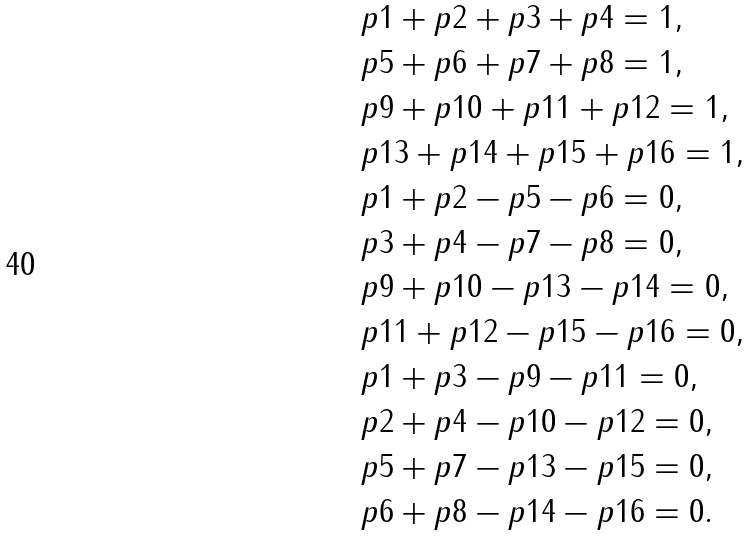<formula> <loc_0><loc_0><loc_500><loc_500>& p 1 + p 2 + p 3 + p 4 = 1 , \\ & p 5 + p 6 + p 7 + p 8 = 1 , \\ & p 9 + p 1 0 + p 1 1 + p 1 2 = 1 , \\ & p 1 3 + p 1 4 + p 1 5 + p 1 6 = 1 , \\ & p 1 + p 2 - p 5 - p 6 = 0 , \\ & p 3 + p 4 - p 7 - p 8 = 0 , \\ & p 9 + p 1 0 - p 1 3 - p 1 4 = 0 , \\ & p 1 1 + p 1 2 - p 1 5 - p 1 6 = 0 , \\ & p 1 + p 3 - p 9 - p 1 1 = 0 , \\ & p 2 + p 4 - p 1 0 - p 1 2 = 0 , \\ & p 5 + p 7 - p 1 3 - p 1 5 = 0 , \\ & p 6 + p 8 - p 1 4 - p 1 6 = 0 .</formula> 